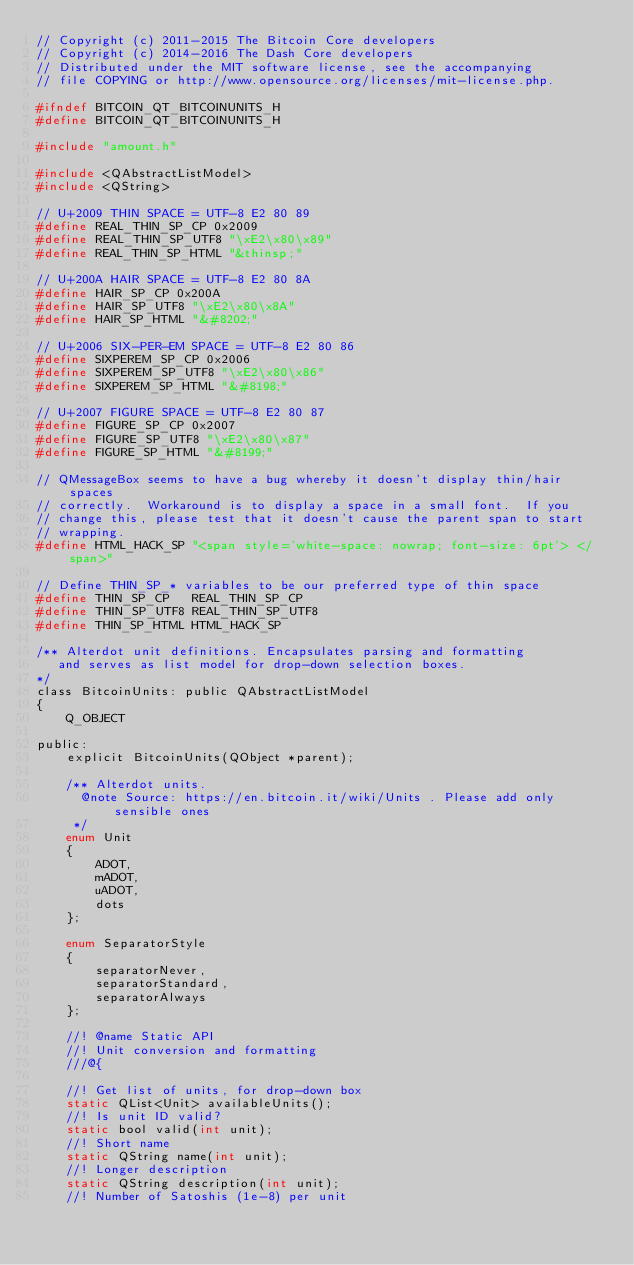<code> <loc_0><loc_0><loc_500><loc_500><_C_>// Copyright (c) 2011-2015 The Bitcoin Core developers
// Copyright (c) 2014-2016 The Dash Core developers
// Distributed under the MIT software license, see the accompanying
// file COPYING or http://www.opensource.org/licenses/mit-license.php.

#ifndef BITCOIN_QT_BITCOINUNITS_H
#define BITCOIN_QT_BITCOINUNITS_H

#include "amount.h"

#include <QAbstractListModel>
#include <QString>

// U+2009 THIN SPACE = UTF-8 E2 80 89
#define REAL_THIN_SP_CP 0x2009
#define REAL_THIN_SP_UTF8 "\xE2\x80\x89"
#define REAL_THIN_SP_HTML "&thinsp;"

// U+200A HAIR SPACE = UTF-8 E2 80 8A
#define HAIR_SP_CP 0x200A
#define HAIR_SP_UTF8 "\xE2\x80\x8A"
#define HAIR_SP_HTML "&#8202;"

// U+2006 SIX-PER-EM SPACE = UTF-8 E2 80 86
#define SIXPEREM_SP_CP 0x2006
#define SIXPEREM_SP_UTF8 "\xE2\x80\x86"
#define SIXPEREM_SP_HTML "&#8198;"

// U+2007 FIGURE SPACE = UTF-8 E2 80 87
#define FIGURE_SP_CP 0x2007
#define FIGURE_SP_UTF8 "\xE2\x80\x87"
#define FIGURE_SP_HTML "&#8199;"

// QMessageBox seems to have a bug whereby it doesn't display thin/hair spaces
// correctly.  Workaround is to display a space in a small font.  If you
// change this, please test that it doesn't cause the parent span to start
// wrapping.
#define HTML_HACK_SP "<span style='white-space: nowrap; font-size: 6pt'> </span>"

// Define THIN_SP_* variables to be our preferred type of thin space
#define THIN_SP_CP   REAL_THIN_SP_CP
#define THIN_SP_UTF8 REAL_THIN_SP_UTF8
#define THIN_SP_HTML HTML_HACK_SP

/** Alterdot unit definitions. Encapsulates parsing and formatting
   and serves as list model for drop-down selection boxes.
*/
class BitcoinUnits: public QAbstractListModel
{
    Q_OBJECT

public:
    explicit BitcoinUnits(QObject *parent);

    /** Alterdot units.
      @note Source: https://en.bitcoin.it/wiki/Units . Please add only sensible ones
     */
    enum Unit
    {
        ADOT,
        mADOT,
        uADOT,
        dots
    };

    enum SeparatorStyle
    {
        separatorNever,
        separatorStandard,
        separatorAlways
    };

    //! @name Static API
    //! Unit conversion and formatting
    ///@{

    //! Get list of units, for drop-down box
    static QList<Unit> availableUnits();
    //! Is unit ID valid?
    static bool valid(int unit);
    //! Short name
    static QString name(int unit);
    //! Longer description
    static QString description(int unit);
    //! Number of Satoshis (1e-8) per unit</code> 